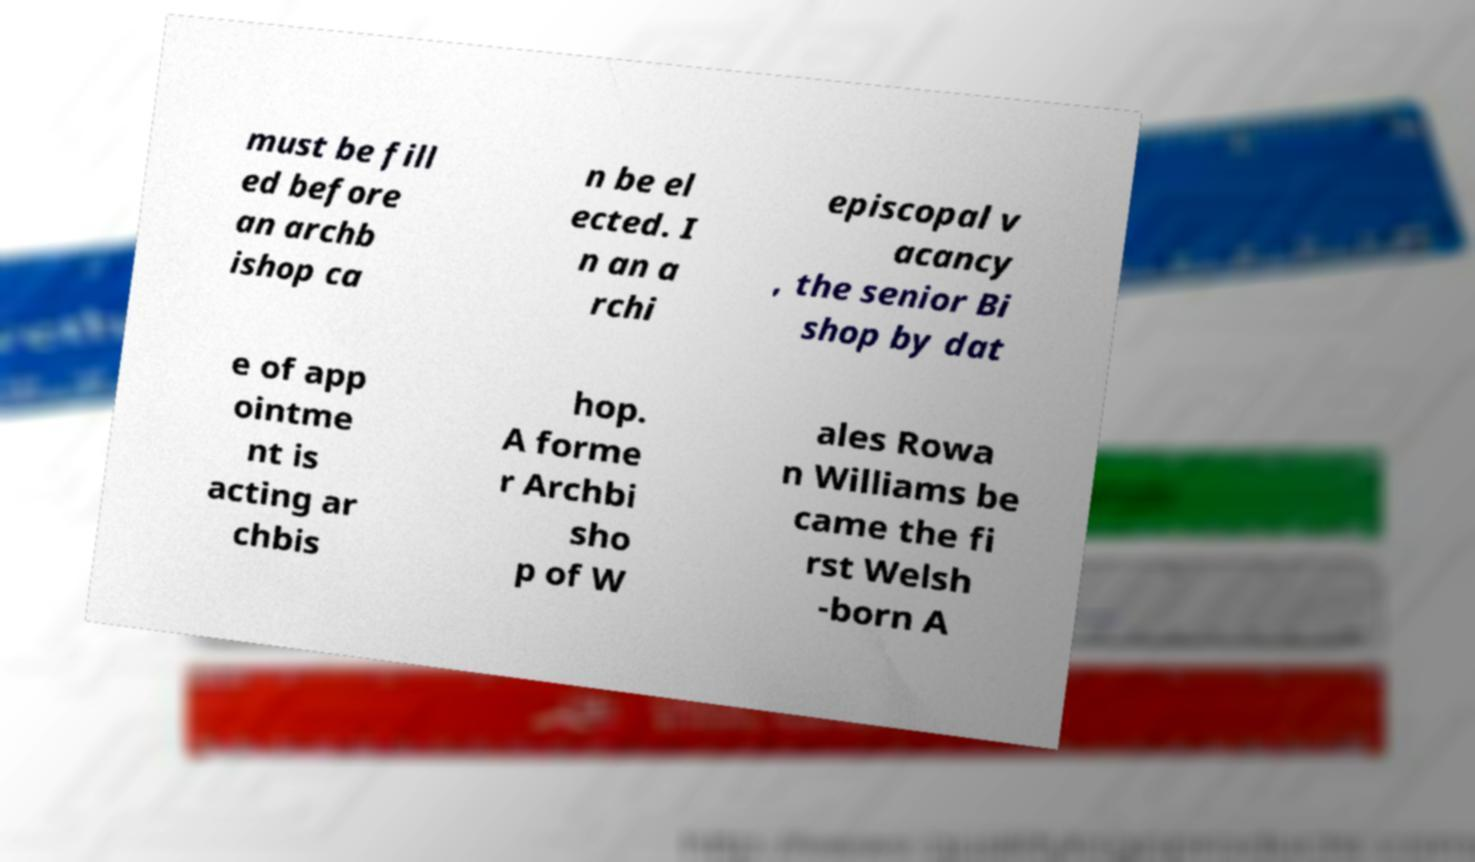I need the written content from this picture converted into text. Can you do that? must be fill ed before an archb ishop ca n be el ected. I n an a rchi episcopal v acancy , the senior Bi shop by dat e of app ointme nt is acting ar chbis hop. A forme r Archbi sho p of W ales Rowa n Williams be came the fi rst Welsh -born A 